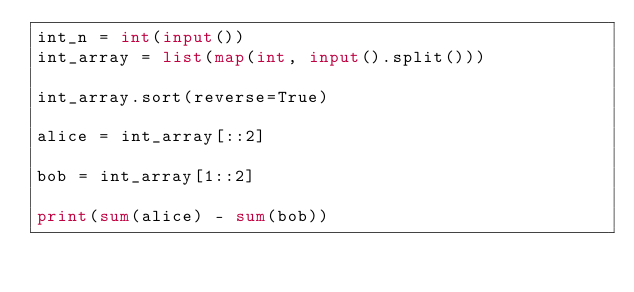<code> <loc_0><loc_0><loc_500><loc_500><_Python_>int_n = int(input())
int_array = list(map(int, input().split()))

int_array.sort(reverse=True)

alice = int_array[::2]

bob = int_array[1::2]

print(sum(alice) - sum(bob))

</code> 